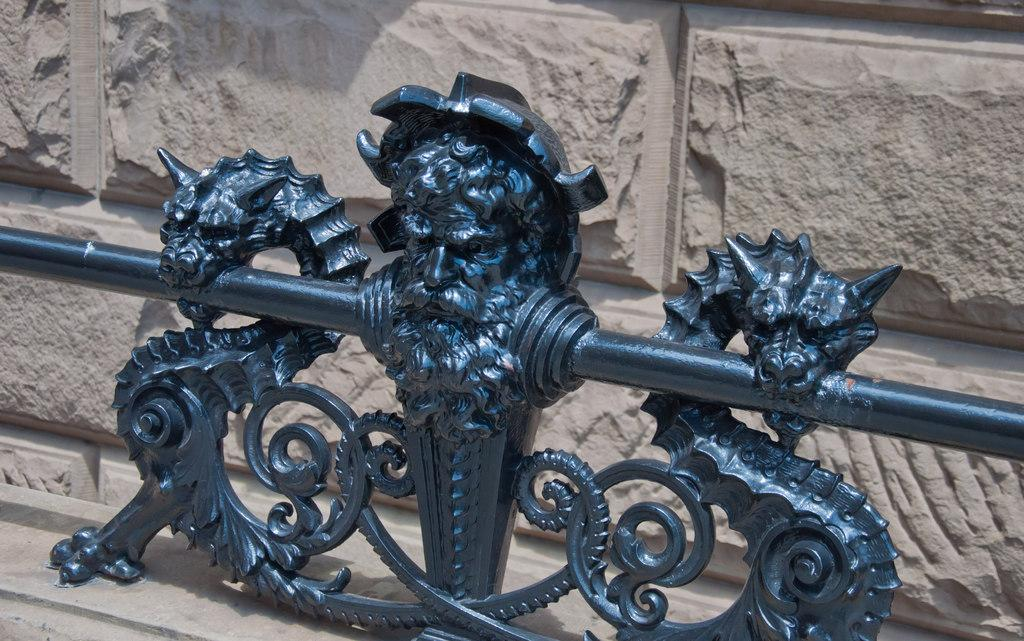What is the main structure visible in the image? There is a wall in the image. What object is placed in front of the wall? There is an iron object in front of the wall. Can you see any goldfish swimming near the iron object in the image? There are no goldfish present in the image. 